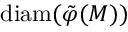<formula> <loc_0><loc_0><loc_500><loc_500>d i a m ( \tilde { \varphi } ( M ) )</formula> 